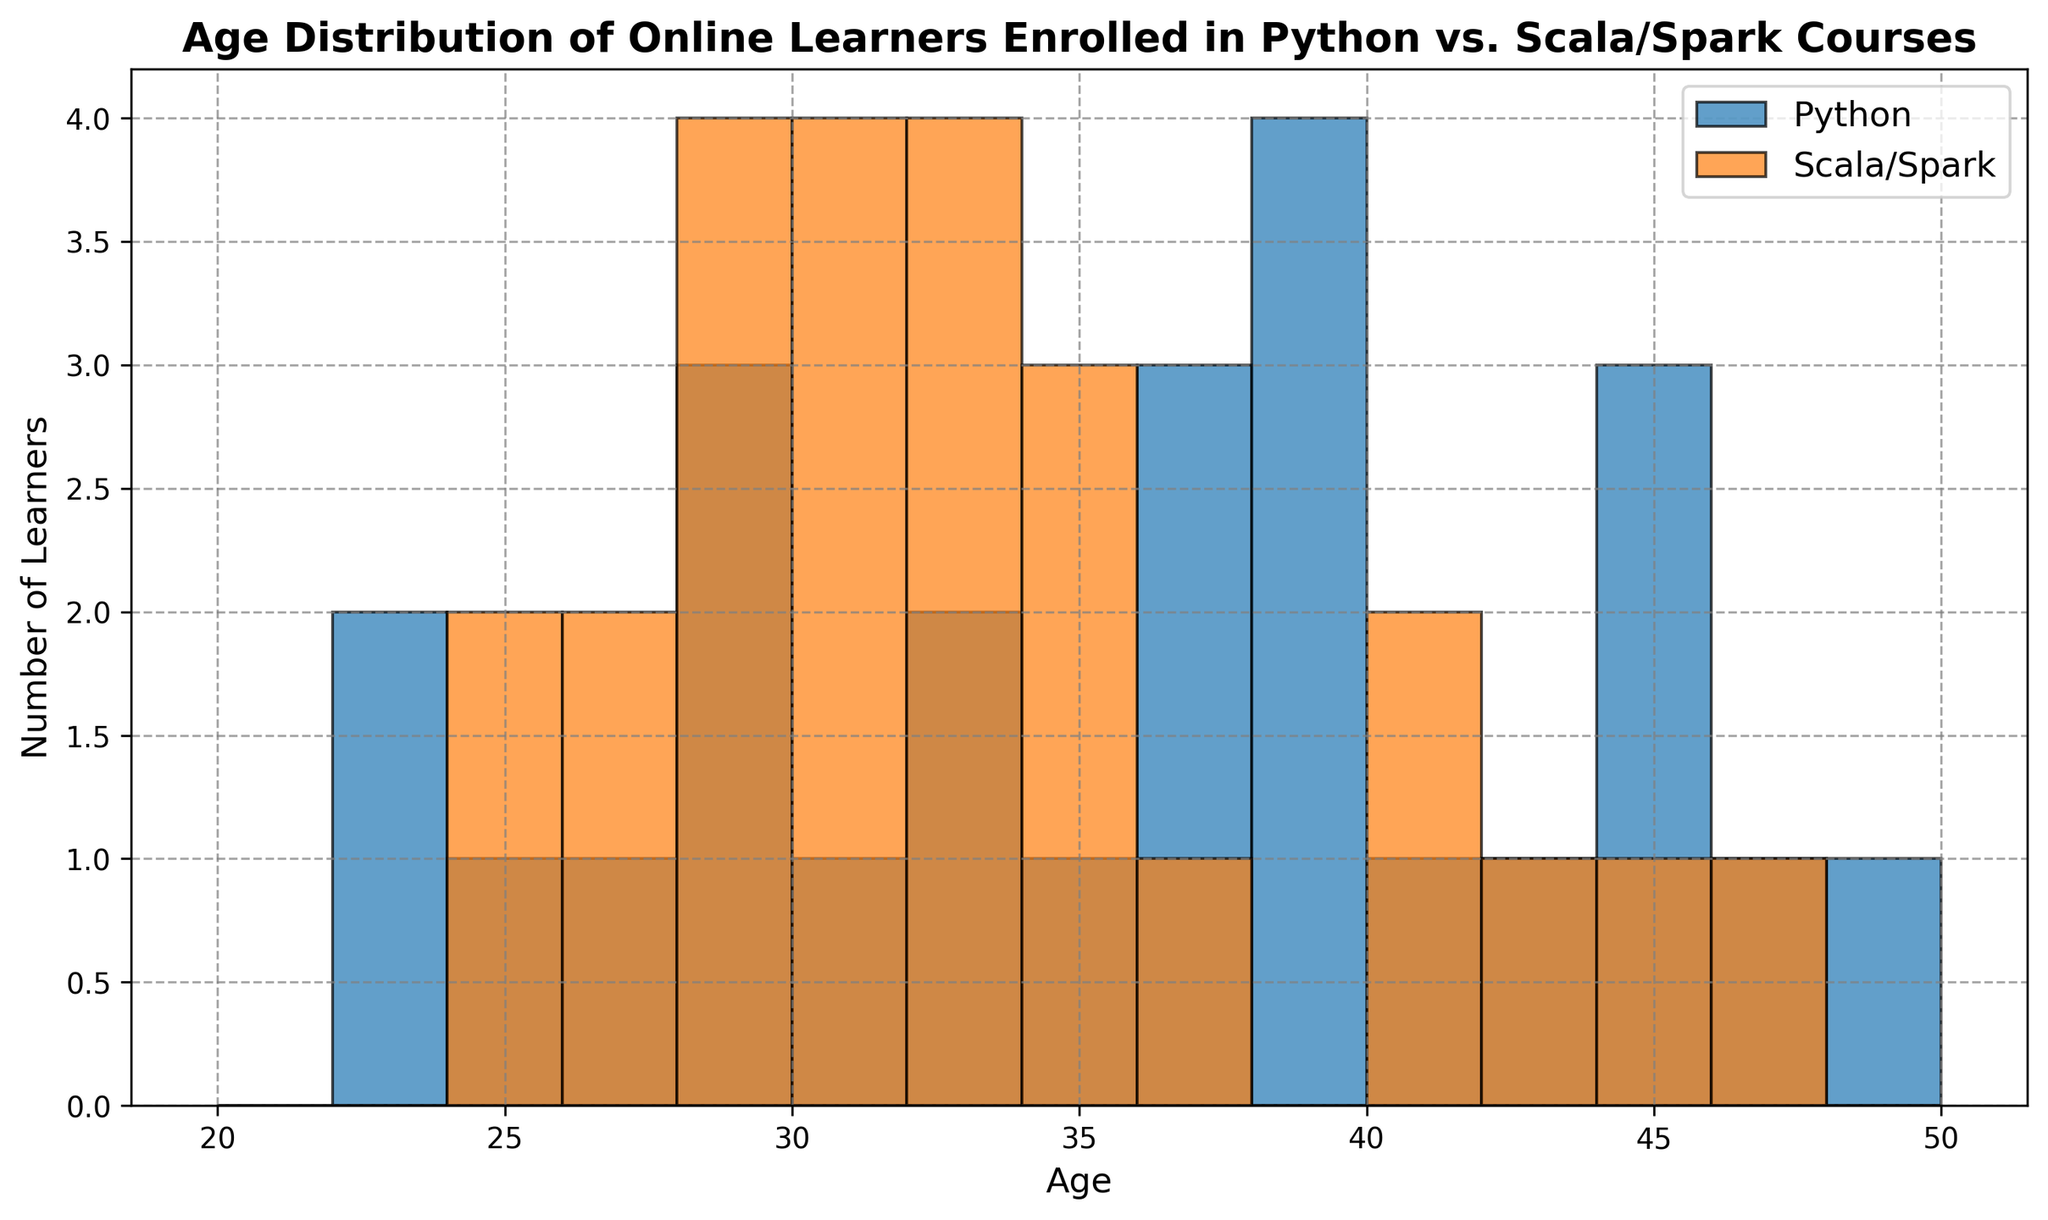How many age categories does the histogram display? The histogram uses bins defined from age 20 to age 50 with 2-year intervals. This results in (50-20)/2 = 15 bins.
Answer: 15 What is the most frequent age range for Python learners? By inspecting the height of the bars in the histogram, we can identify that the tallest bar for Python learners corresponds to ages 28 to 30 and 36 to 38.
Answer: 28-30 and 36-38 Which course has more learners in the age range 40-42? By comparing the heights of the histogram bars for 40-42 age range, Scala/Spark has a higher bar than Python.
Answer: Scala/Spark Are there any age ranges where Python learners are not present? We note the absence of bars for Python in the age ranges of 24-26 and 46-48.
Answer: 24-26 and 46-48 What is the total number of learners aged between 30 and 34 inclusive in both courses? Summing the counts for ages 30-32 and 32-34 from both Python and Scala/Spark courses, we find the frequency and add them.
Answer: 12 Which course shows a more even distribution of learners across ages? By observing the histogram, Scala/Spark displays a more even distribution with less variation in bar heights while Python shows a higher variation.
Answer: Scala/Spark What are the central tendencies observed in the age distributions for each course? Comparing the spreads and central peaks of both histograms, Python shows peaks in mid-20s and late-30s, while Scala/Spark tends to peak in early-30s to mid-30s.
Answer: Python: mid-20s, late-30s; Scala/Spark: early-30s, mid-30s 